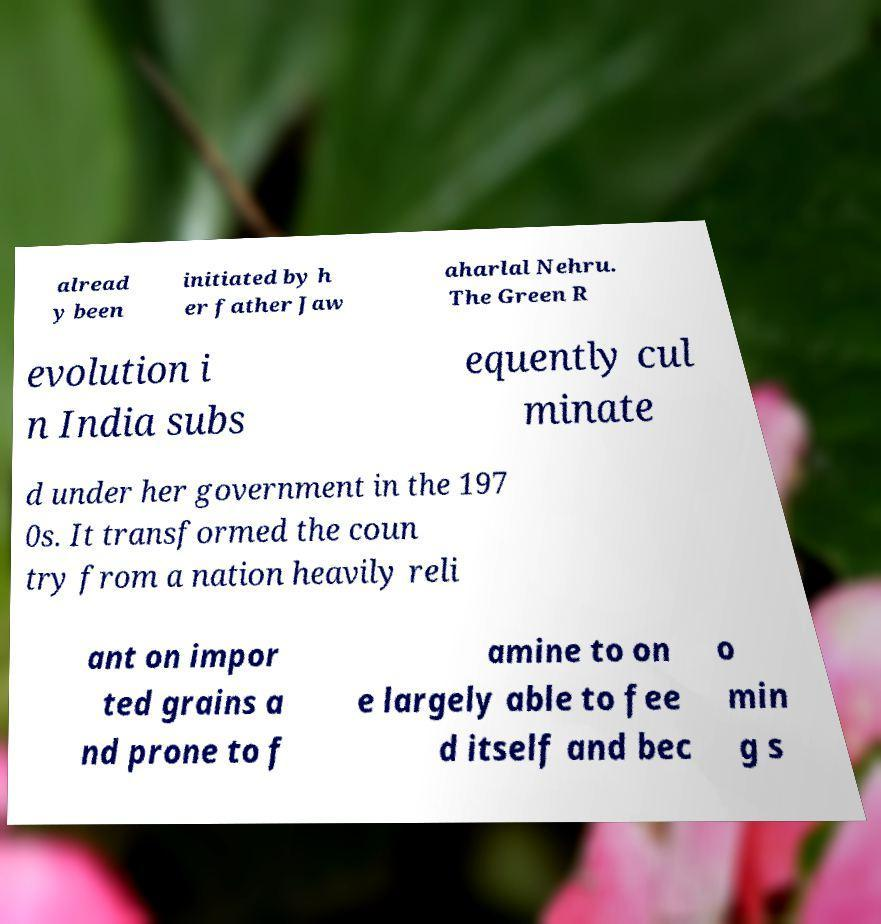Can you read and provide the text displayed in the image?This photo seems to have some interesting text. Can you extract and type it out for me? alread y been initiated by h er father Jaw aharlal Nehru. The Green R evolution i n India subs equently cul minate d under her government in the 197 0s. It transformed the coun try from a nation heavily reli ant on impor ted grains a nd prone to f amine to on e largely able to fee d itself and bec o min g s 